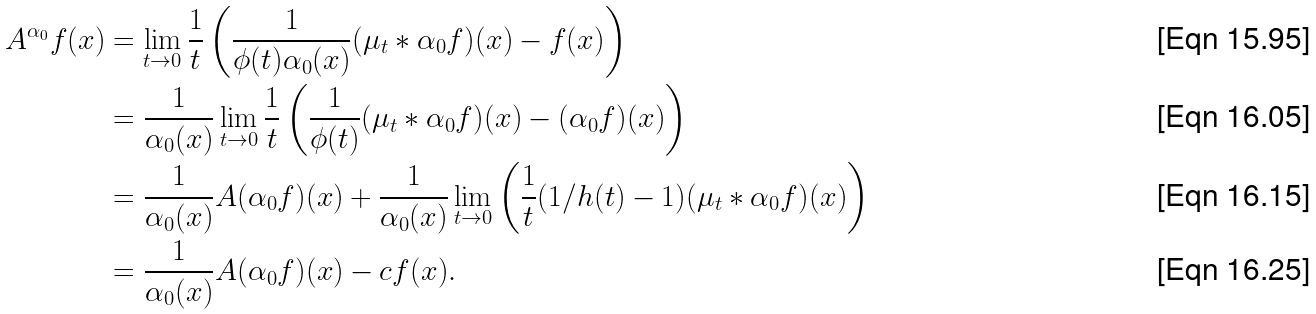<formula> <loc_0><loc_0><loc_500><loc_500>A ^ { \alpha _ { 0 } } f ( x ) & = \lim _ { t \to 0 } \frac { 1 } { t } \left ( \frac { 1 } { \phi ( t ) \alpha _ { 0 } ( x ) } ( \mu _ { t } * \alpha _ { 0 } f ) ( x ) - f ( x ) \right ) \\ & = \frac { 1 } { \alpha _ { 0 } ( x ) } \lim _ { t \to 0 } \frac { 1 } { t } \left ( \frac { 1 } { \phi ( t ) } ( \mu _ { t } * \alpha _ { 0 } f ) ( x ) - ( \alpha _ { 0 } f ) ( x ) \right ) \\ & = \frac { 1 } { \alpha _ { 0 } ( x ) } A ( \alpha _ { 0 } f ) ( x ) + \frac { 1 } { \alpha _ { 0 } ( x ) } \lim _ { t \to 0 } \left ( \frac { 1 } { t } ( 1 / h ( t ) - 1 ) ( \mu _ { t } * \alpha _ { 0 } f ) ( x ) \right ) \\ & = \frac { 1 } { \alpha _ { 0 } ( x ) } A ( \alpha _ { 0 } f ) ( x ) - c f ( x ) .</formula> 